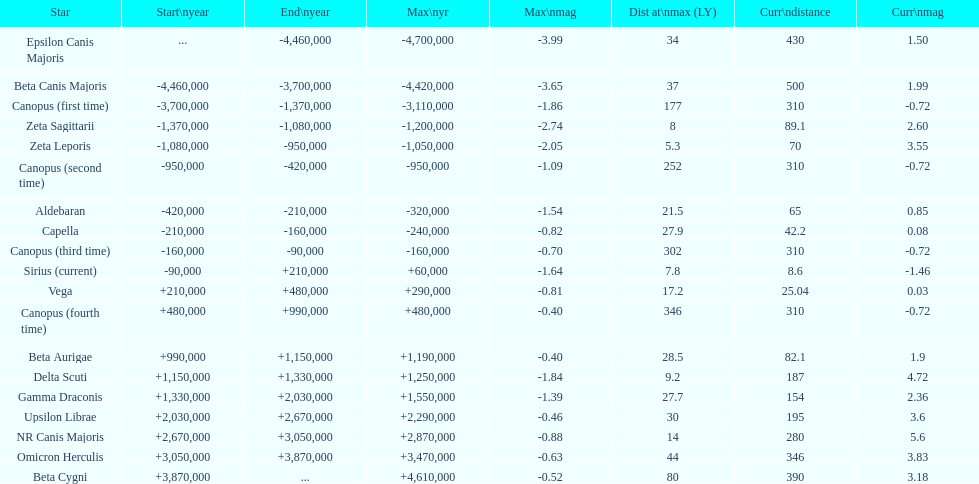By how many light years is epsilon canis majoris further than zeta sagittarii? 26. 